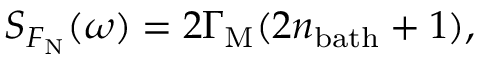Convert formula to latex. <formula><loc_0><loc_0><loc_500><loc_500>S _ { F _ { N } } ( \omega ) = 2 \Gamma _ { M } ( 2 n _ { b a t h } + 1 ) ,</formula> 